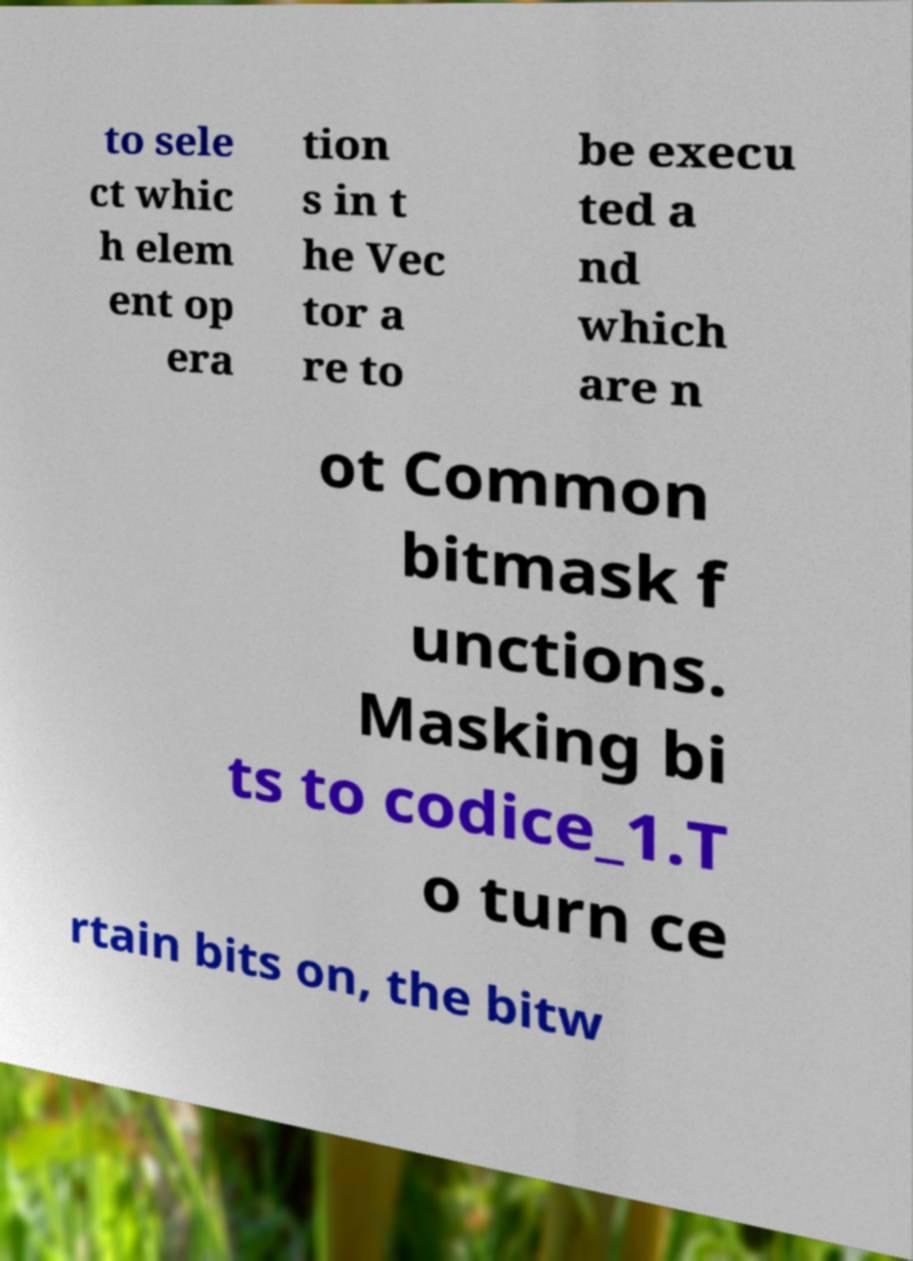Could you assist in decoding the text presented in this image and type it out clearly? to sele ct whic h elem ent op era tion s in t he Vec tor a re to be execu ted a nd which are n ot Common bitmask f unctions. Masking bi ts to codice_1.T o turn ce rtain bits on, the bitw 